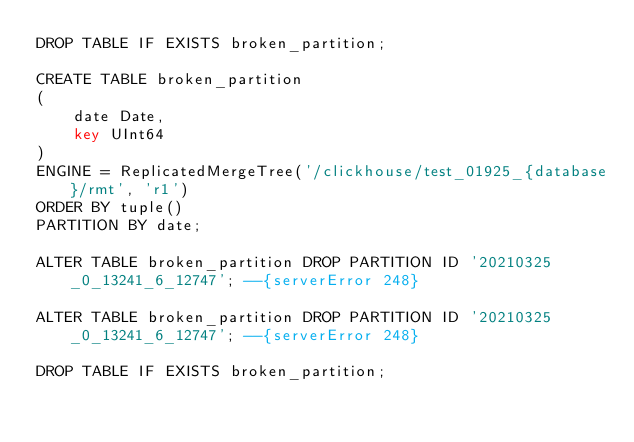<code> <loc_0><loc_0><loc_500><loc_500><_SQL_>DROP TABLE IF EXISTS broken_partition;

CREATE TABLE broken_partition
(
    date Date,
    key UInt64
)
ENGINE = ReplicatedMergeTree('/clickhouse/test_01925_{database}/rmt', 'r1')
ORDER BY tuple()
PARTITION BY date;

ALTER TABLE broken_partition DROP PARTITION ID '20210325_0_13241_6_12747'; --{serverError 248}

ALTER TABLE broken_partition DROP PARTITION ID '20210325_0_13241_6_12747'; --{serverError 248}

DROP TABLE IF EXISTS broken_partition;
</code> 